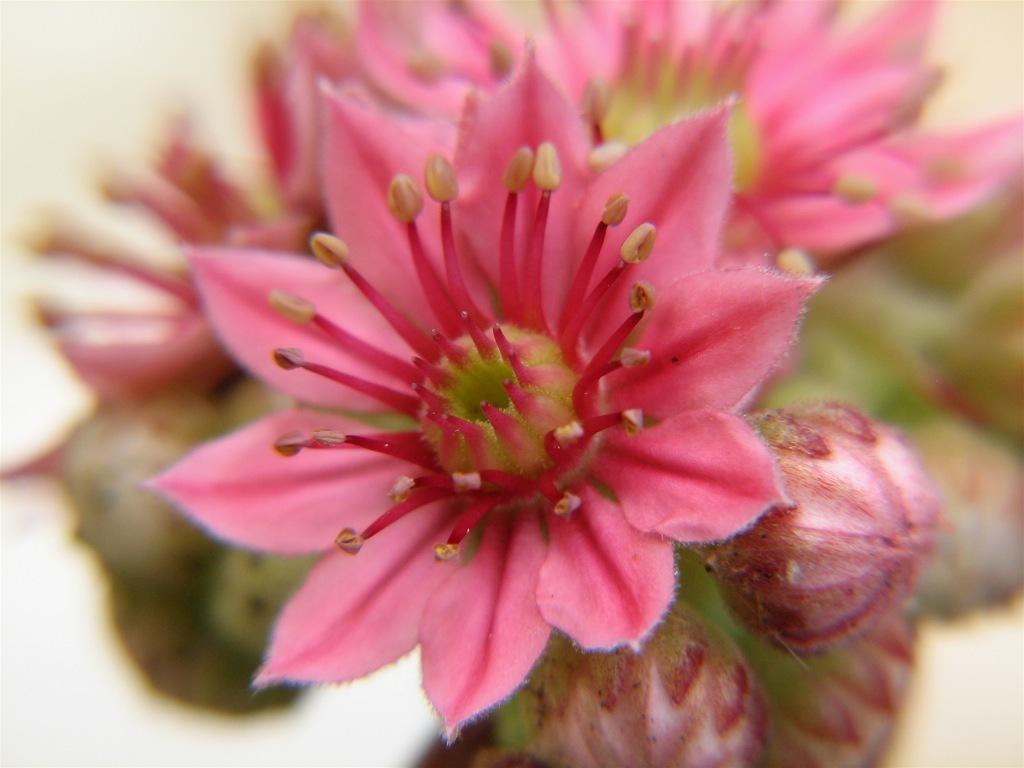In one or two sentences, can you explain what this image depicts? In this image we can see the flowers and also the buds. 